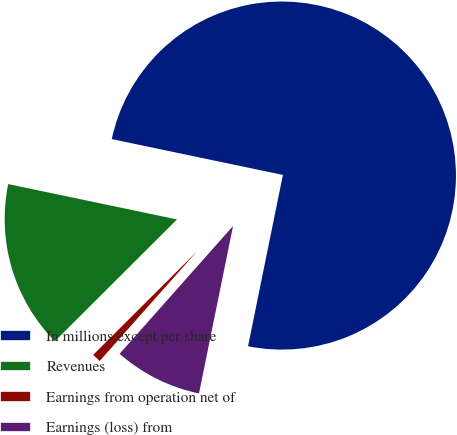Convert chart. <chart><loc_0><loc_0><loc_500><loc_500><pie_chart><fcel>In millions except per share<fcel>Revenues<fcel>Earnings from operation net of<fcel>Earnings (loss) from<nl><fcel>74.91%<fcel>15.76%<fcel>0.97%<fcel>8.36%<nl></chart> 